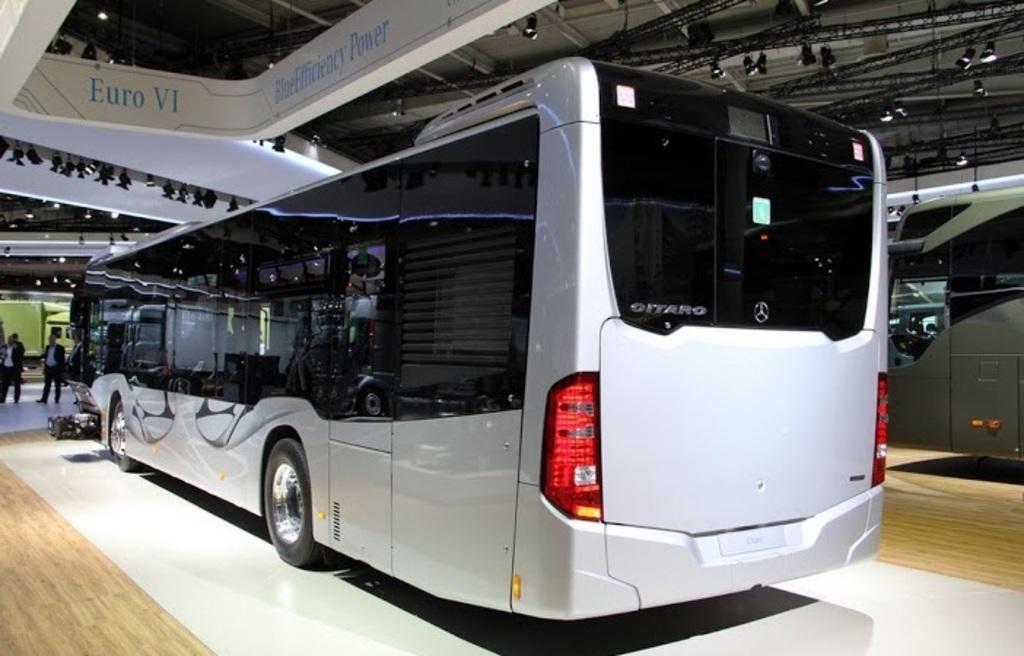Can you describe this image briefly? Here in this picture we can see a couple of buses present on the floor and in front of those we can see people standing and walking on the floor and above them we can see a shed present and we can see iron frames covered all over there and we can see lights present on the frame. 